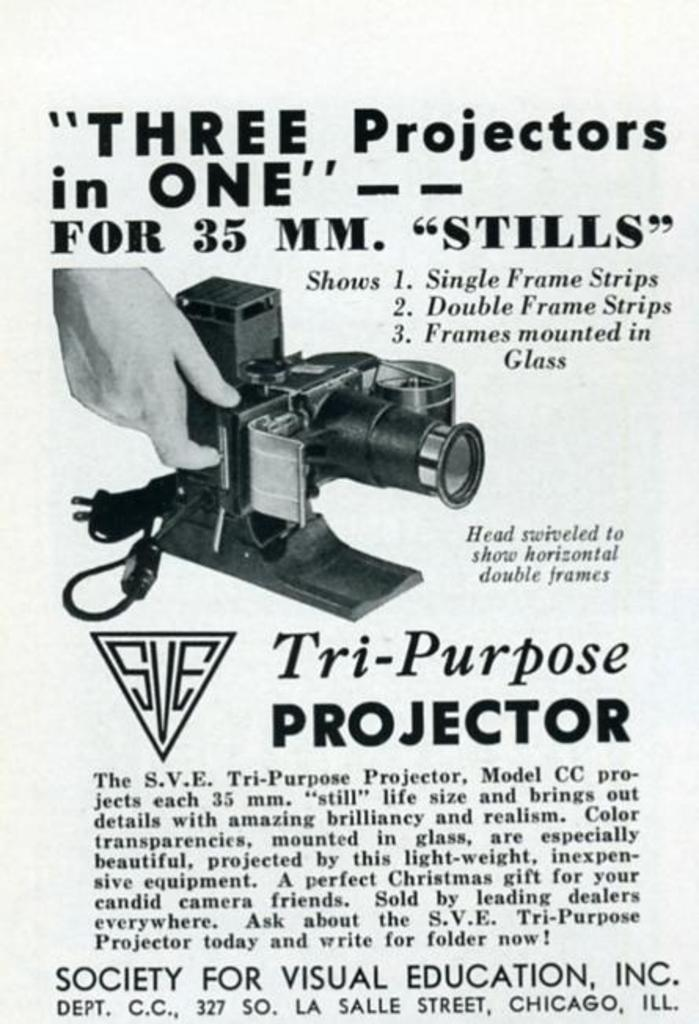<image>
Provide a brief description of the given image. A sign with a projector on it advertising three projects in one. 